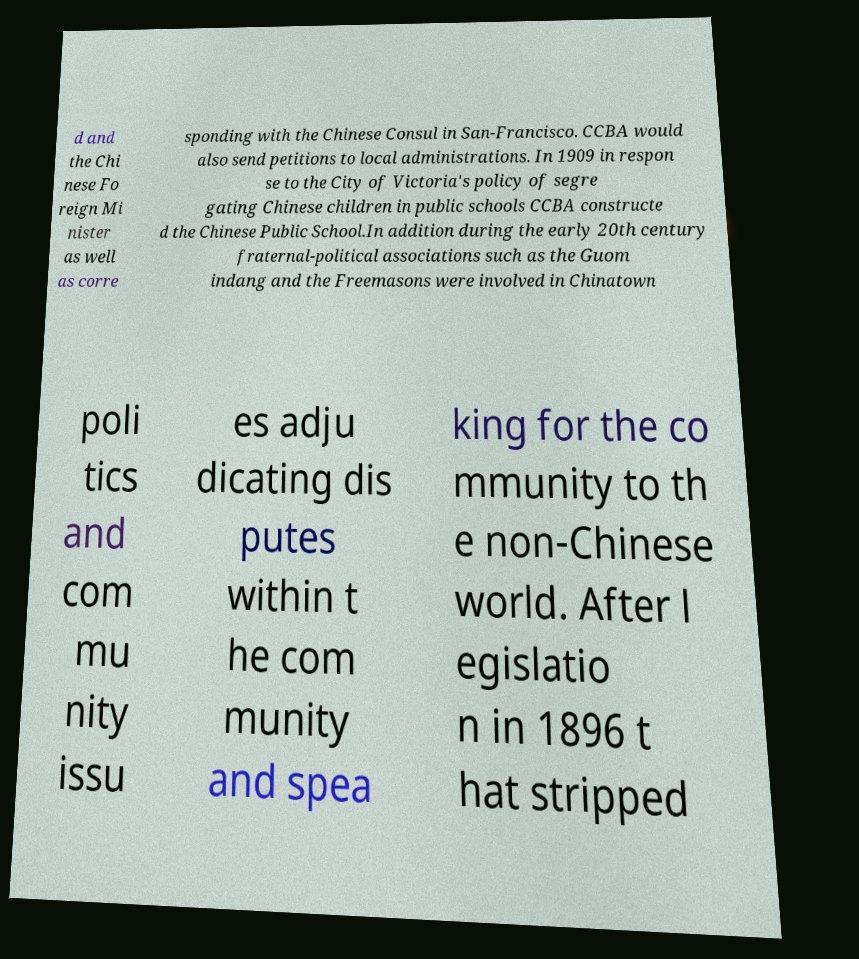What messages or text are displayed in this image? I need them in a readable, typed format. d and the Chi nese Fo reign Mi nister as well as corre sponding with the Chinese Consul in San-Francisco. CCBA would also send petitions to local administrations. In 1909 in respon se to the City of Victoria's policy of segre gating Chinese children in public schools CCBA constructe d the Chinese Public School.In addition during the early 20th century fraternal-political associations such as the Guom indang and the Freemasons were involved in Chinatown poli tics and com mu nity issu es adju dicating dis putes within t he com munity and spea king for the co mmunity to th e non-Chinese world. After l egislatio n in 1896 t hat stripped 